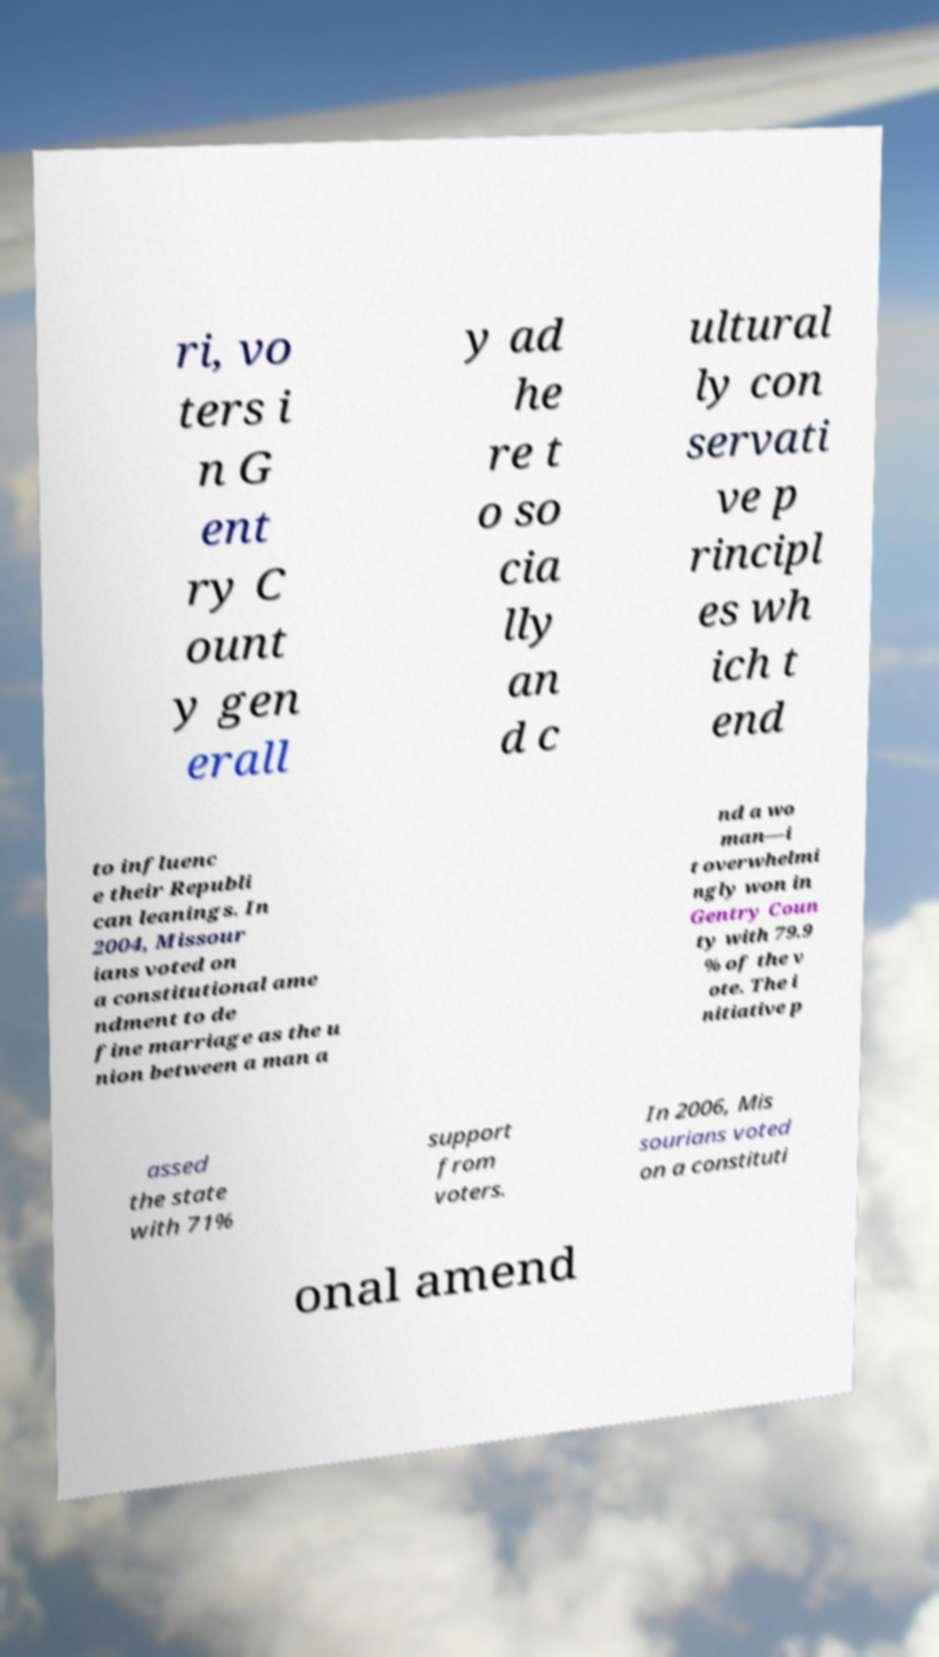Please read and relay the text visible in this image. What does it say? ri, vo ters i n G ent ry C ount y gen erall y ad he re t o so cia lly an d c ultural ly con servati ve p rincipl es wh ich t end to influenc e their Republi can leanings. In 2004, Missour ians voted on a constitutional ame ndment to de fine marriage as the u nion between a man a nd a wo man—i t overwhelmi ngly won in Gentry Coun ty with 79.9 % of the v ote. The i nitiative p assed the state with 71% support from voters. In 2006, Mis sourians voted on a constituti onal amend 